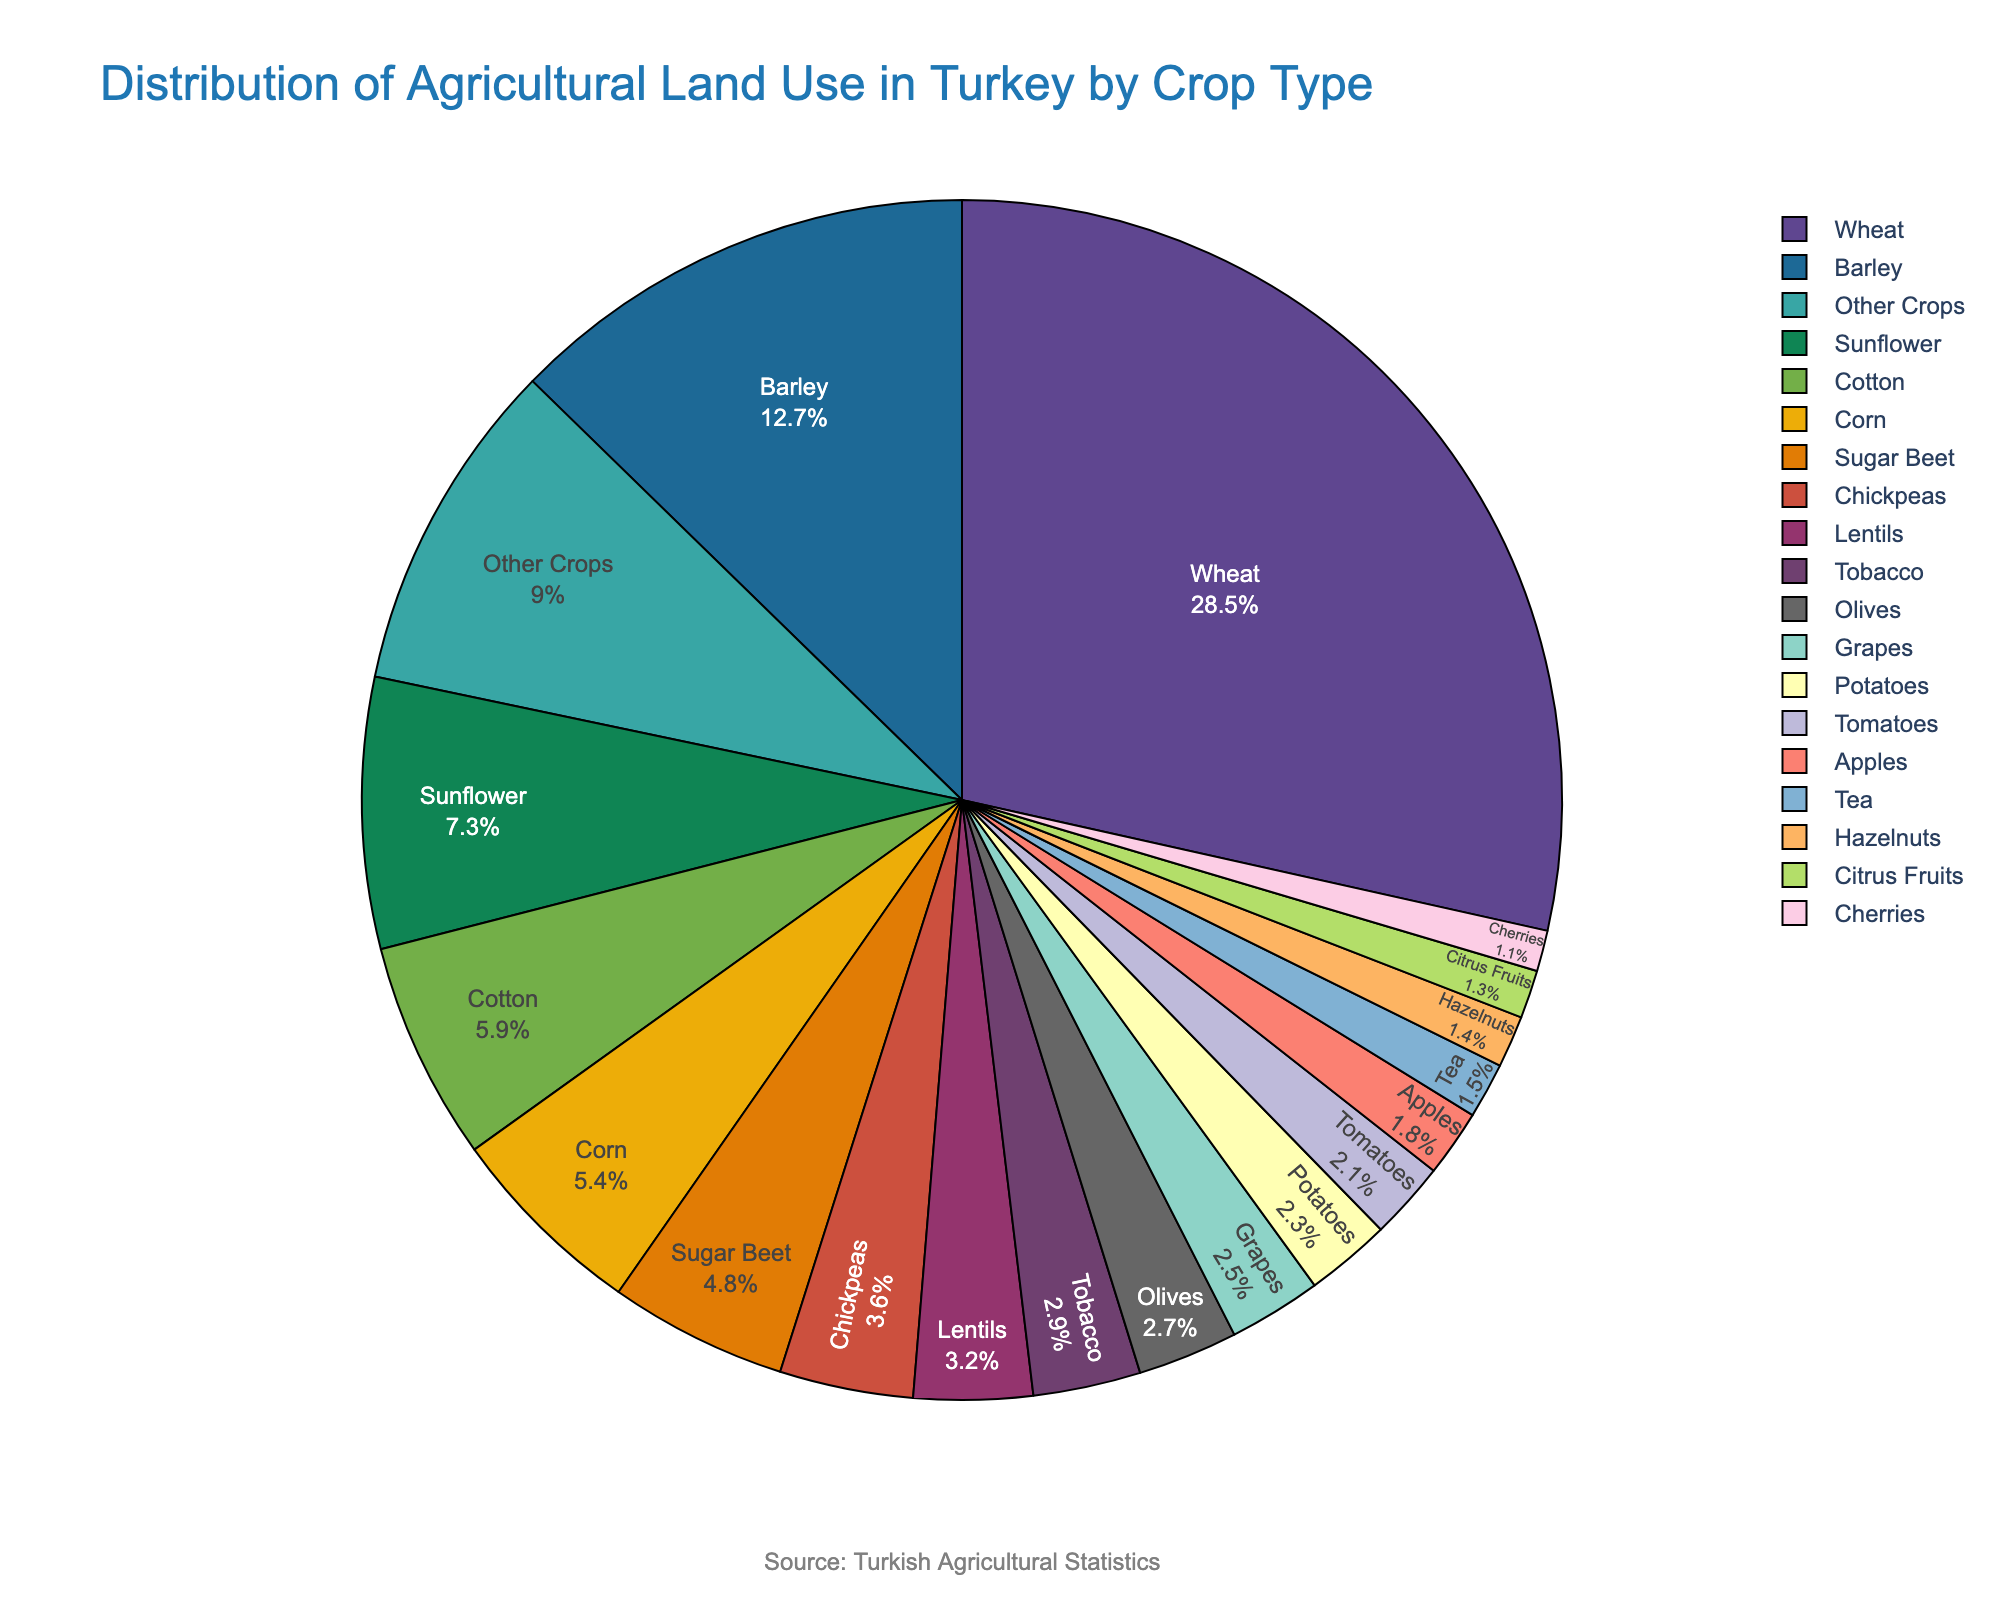What percentage of agricultural land is used for wheat? The pie chart shows the percentage distribution of different crop types. Locate wheat and its corresponding percentage.
Answer: 28.5% Which crop uses more land, barley or sunflower? Compare the percentages of agricultural land use for barley and sunflower on the pie chart. Barley has 12.7% while sunflower has 7.3%.
Answer: Barley What is the combined percentage of land used for cotton and corn? Find the percentages for cotton and corn in the pie chart and add them together: 5.9% (cotton) + 5.4% (corn) = 11.3%.
Answer: 11.3% How much more land is used for wheat compared to tobacco? Calculate the difference between the percentages for wheat and tobacco: 28.5% (wheat) - 2.9% (tobacco) = 25.6%.
Answer: 25.6% Which crop type uses the smallest amount of land, and what is its percentage? Examine the pie chart for the crop type with the smallest percentage. Cherries represent the smallest amount of land with 1.1%.
Answer: Cherries, 1.1% Are there more agricultural lands used for tomatoes or for apples? Compare the percentages for tomatoes and apples on the pie chart. Tomatoes have 2.1%, while apples have 1.8%.
Answer: Tomatoes What is the total percentage of land used for all the crop types that are 3.6% or above? Identify the crops with 3.6% or higher values: Wheat (28.5%), Barley (12.7%), Sunflower (7.3%), Cotton (5.9%), Corn (5.4%), Sugar Beet (4.8%), and Chickpeas (3.6%). Sum these percentages: 28.5 + 12.7 + 7.3 + 5.9 + 5.4 + 4.8 + 3.6 = 68.2%.
Answer: 68.2% Which crop has a visual representation in green, and what is its percentage? Look for the green colored section in the pie chart. Corn is represented in green with a percentage of 5.4%.
Answer: Corn, 5.4% How does the land use percentage for lentils compare to hazelnuts? Check the percentages for lentils and hazelnuts on the pie chart. Lentils have 3.2% and hazelnuts have 1.4%. So, lentils use more land.
Answer: Lentils What is the average percentage use of land for tea, hazelnuts, and citrus fruits? Find the percentages for tea (1.5%), hazelnuts (1.4%), and citrus fruits (1.3%), then calculate the average: (1.5 + 1.4 + 1.3) / 3 = 1.4%.
Answer: 1.4% 